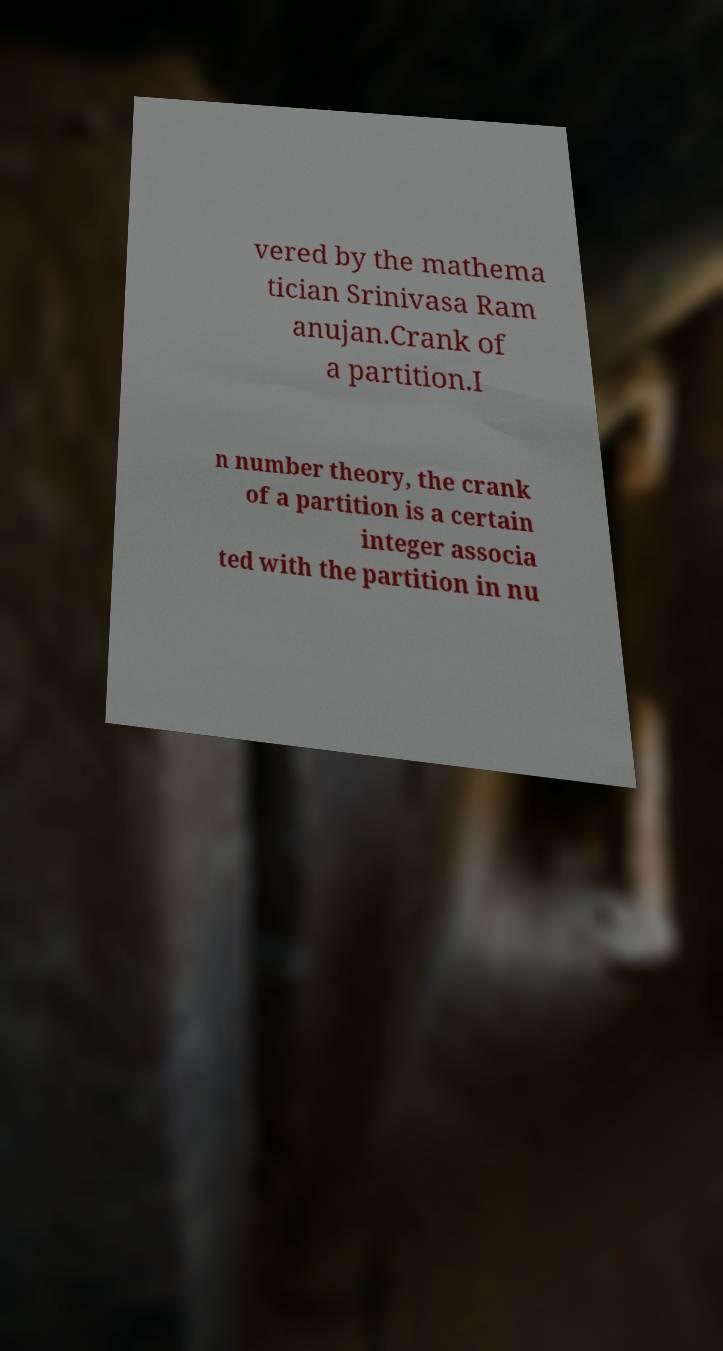Could you extract and type out the text from this image? vered by the mathema tician Srinivasa Ram anujan.Crank of a partition.I n number theory, the crank of a partition is a certain integer associa ted with the partition in nu 